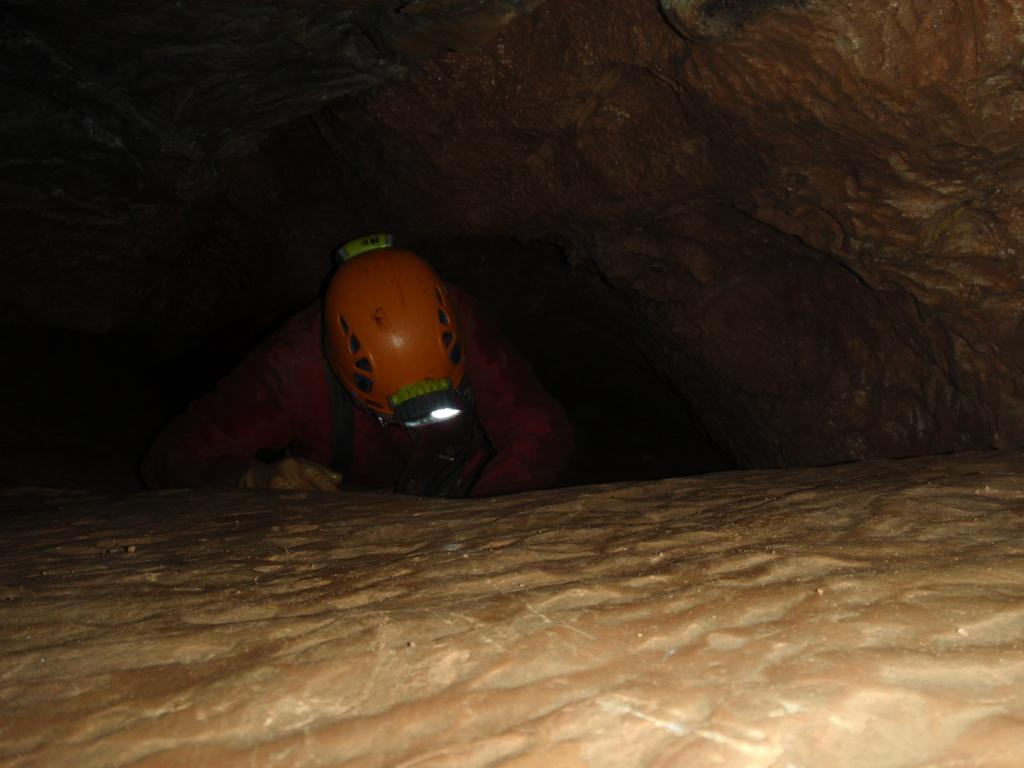What is the main subject of the image? There is a person in the image. What is the person wearing? The person is wearing a helmet. Where is the person standing in the image? The person is standing between hills. What type of root can be seen growing near the person in the image? There is no root visible in the image; the person is standing between hills. 